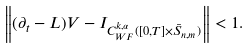Convert formula to latex. <formula><loc_0><loc_0><loc_500><loc_500>\left \| ( \partial _ { t } - L ) V - I _ { C ^ { k , \alpha } _ { W F } ( [ 0 , T ] \times \bar { S } _ { n , m } ) } \right \| < 1 .</formula> 